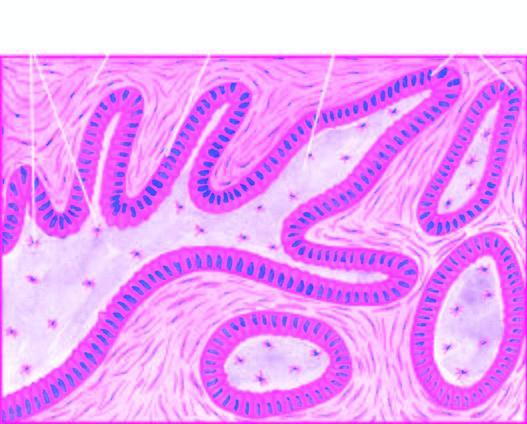what are composed of central area of stellate cells and peripheral layer of cuboidal or columnar cells?
Answer the question using a single word or phrase. Epithelial follicles 